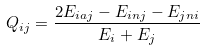Convert formula to latex. <formula><loc_0><loc_0><loc_500><loc_500>Q _ { i j } = \frac { 2 E _ { i a j } - E _ { i n j } - E _ { j n i } } { E _ { i } + E _ { j } }</formula> 